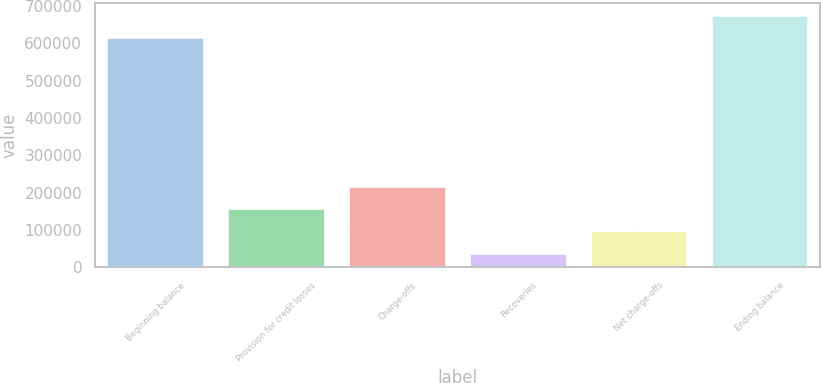Convert chart to OTSL. <chart><loc_0><loc_0><loc_500><loc_500><bar_chart><fcel>Beginning balance<fcel>Provision for credit losses<fcel>Charge-offs<fcel>Recoveries<fcel>Net charge-offs<fcel>Ending balance<nl><fcel>614058<fcel>155238<fcel>214192<fcel>37332<fcel>96285.2<fcel>673011<nl></chart> 